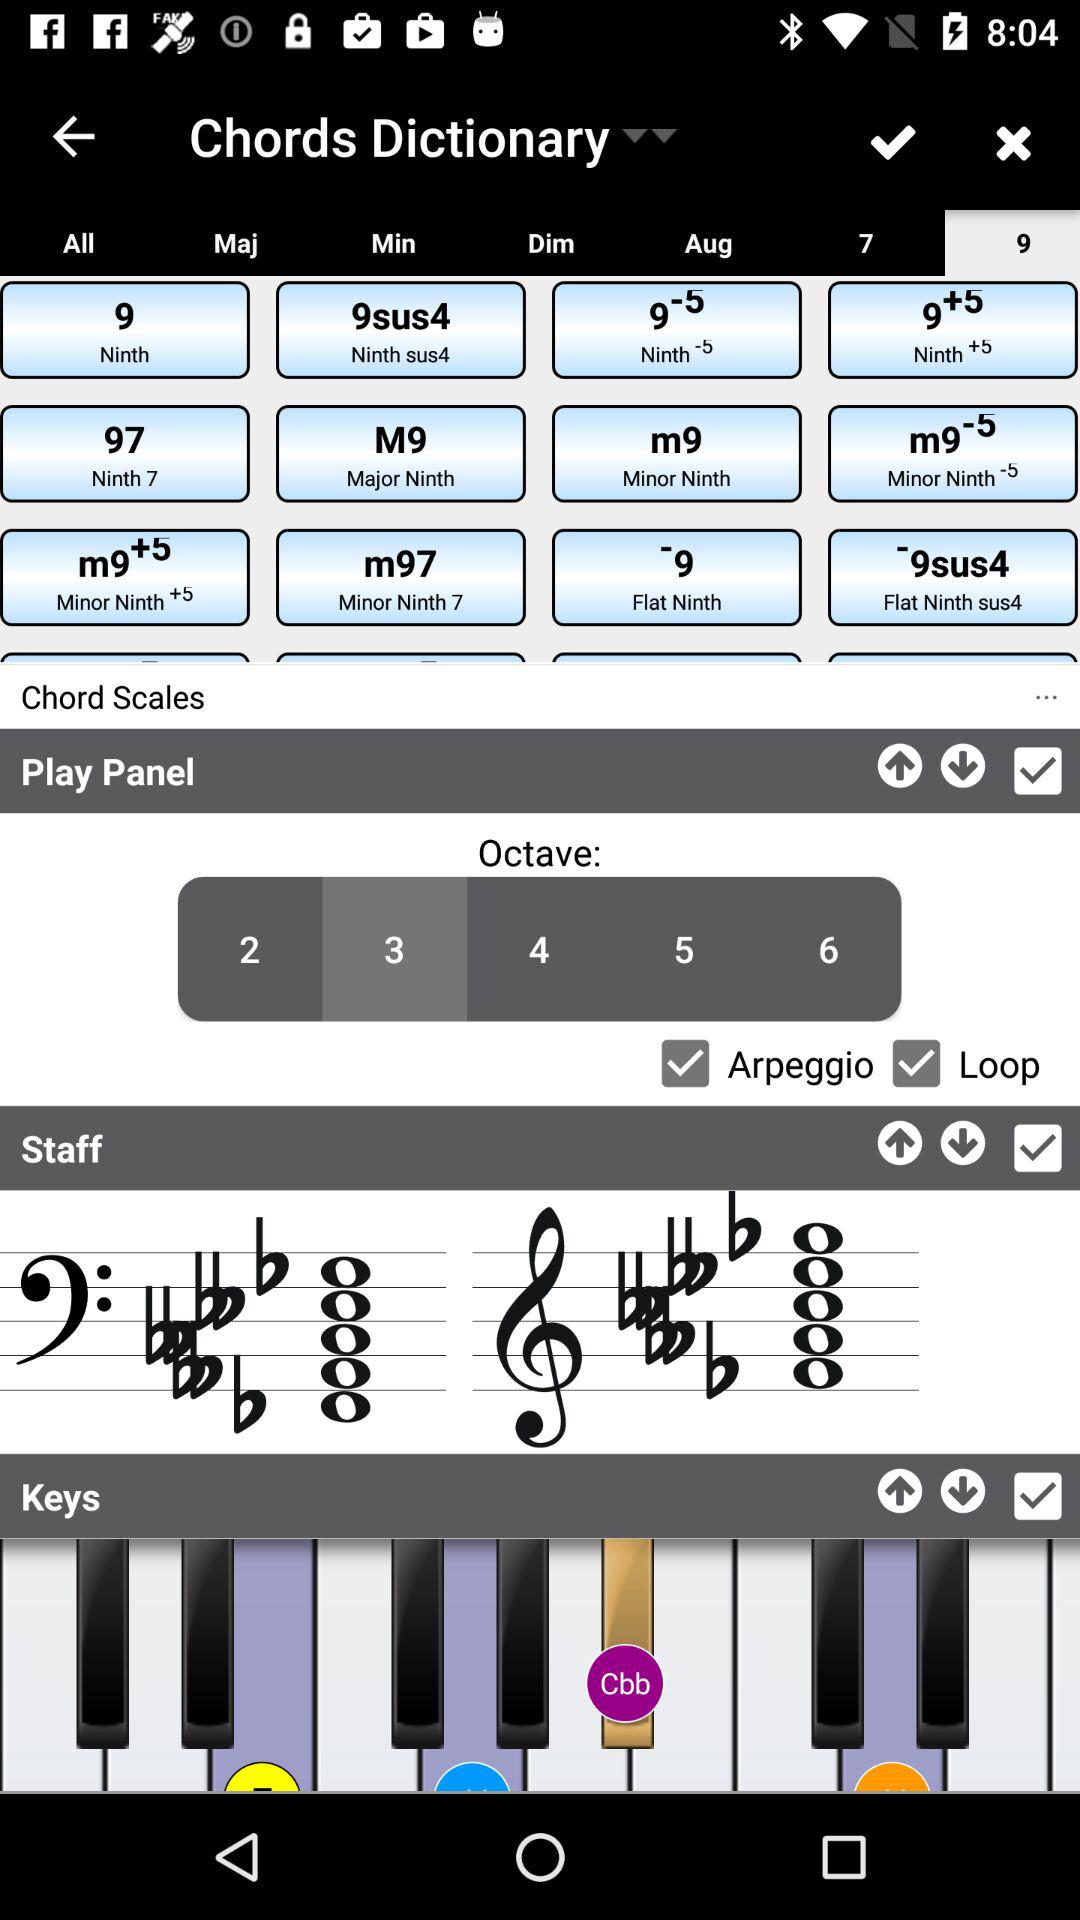Which number is selected for "Octave"? The selected number for "Octave" is 3. 